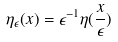<formula> <loc_0><loc_0><loc_500><loc_500>\eta _ { \epsilon } ( x ) = \epsilon ^ { - 1 } \eta ( \frac { x } { \epsilon } )</formula> 